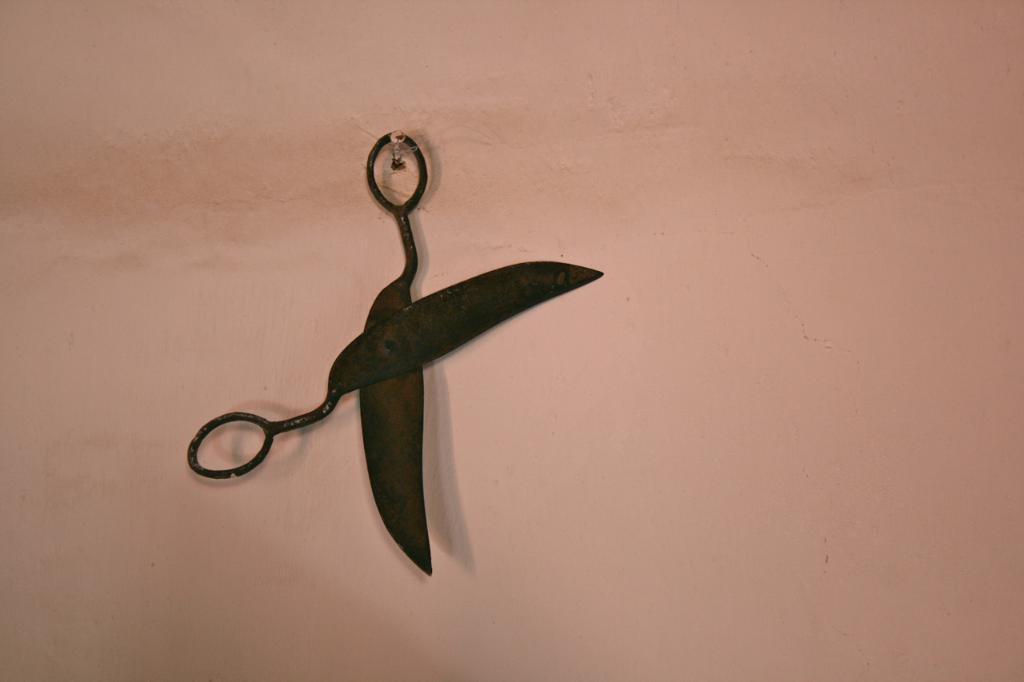What object is hanging from a nail in the image? There is a scissor in the image, and it is hanging from a nail. Where is the nail attached in the image? The nail is attached to a wall. What type of heart is visible in the image? There is no heart present in the image; it features a scissor hanging from a nail on a wall. 